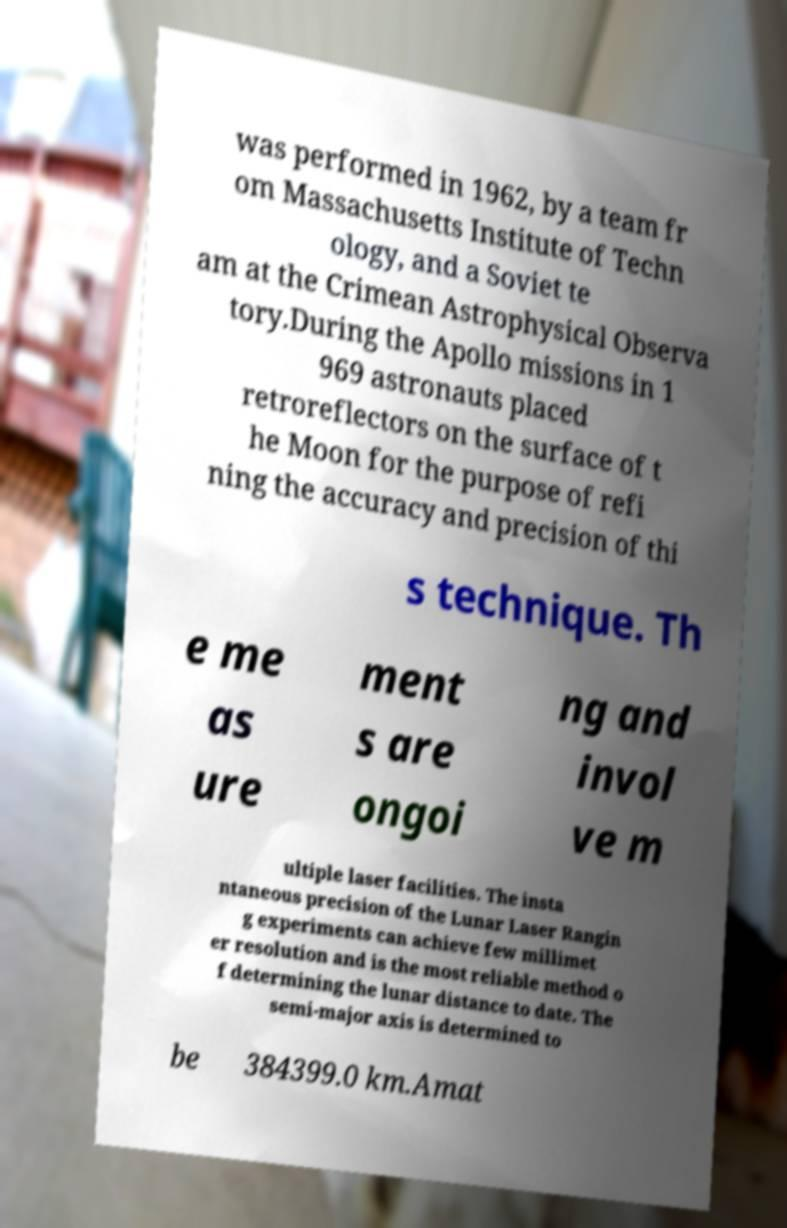Can you accurately transcribe the text from the provided image for me? was performed in 1962, by a team fr om Massachusetts Institute of Techn ology, and a Soviet te am at the Crimean Astrophysical Observa tory.During the Apollo missions in 1 969 astronauts placed retroreflectors on the surface of t he Moon for the purpose of refi ning the accuracy and precision of thi s technique. Th e me as ure ment s are ongoi ng and invol ve m ultiple laser facilities. The insta ntaneous precision of the Lunar Laser Rangin g experiments can achieve few millimet er resolution and is the most reliable method o f determining the lunar distance to date. The semi-major axis is determined to be 384399.0 km.Amat 